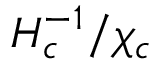Convert formula to latex. <formula><loc_0><loc_0><loc_500><loc_500>{ H _ { c } ^ { - 1 } } / { \chi _ { c } }</formula> 